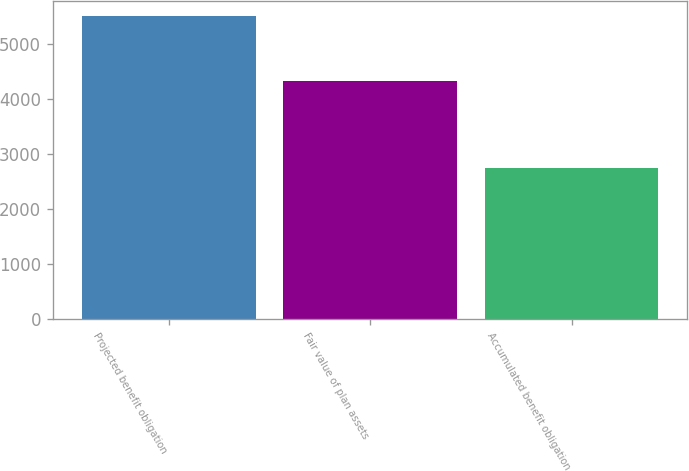Convert chart. <chart><loc_0><loc_0><loc_500><loc_500><bar_chart><fcel>Projected benefit obligation<fcel>Fair value of plan assets<fcel>Accumulated benefit obligation<nl><fcel>5513<fcel>4341<fcel>2749<nl></chart> 